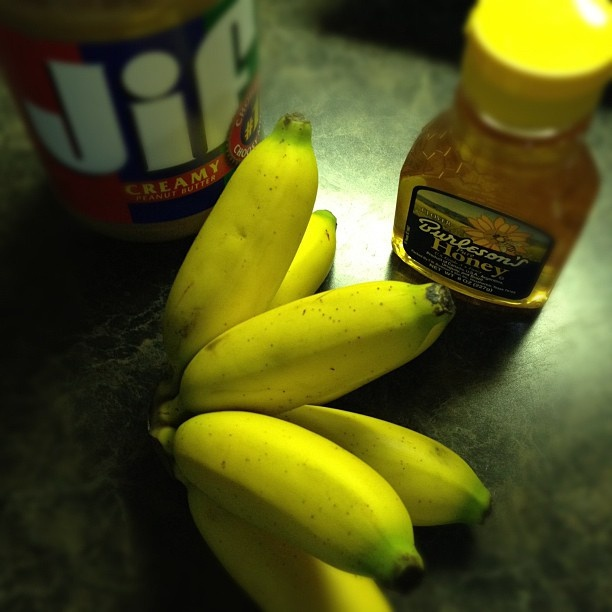Describe the objects in this image and their specific colors. I can see bottle in black and darkgreen tones, bottle in black, olive, maroon, and yellow tones, banana in black, olive, and yellow tones, banana in black, yellow, and olive tones, and banana in black, olive, and yellow tones in this image. 